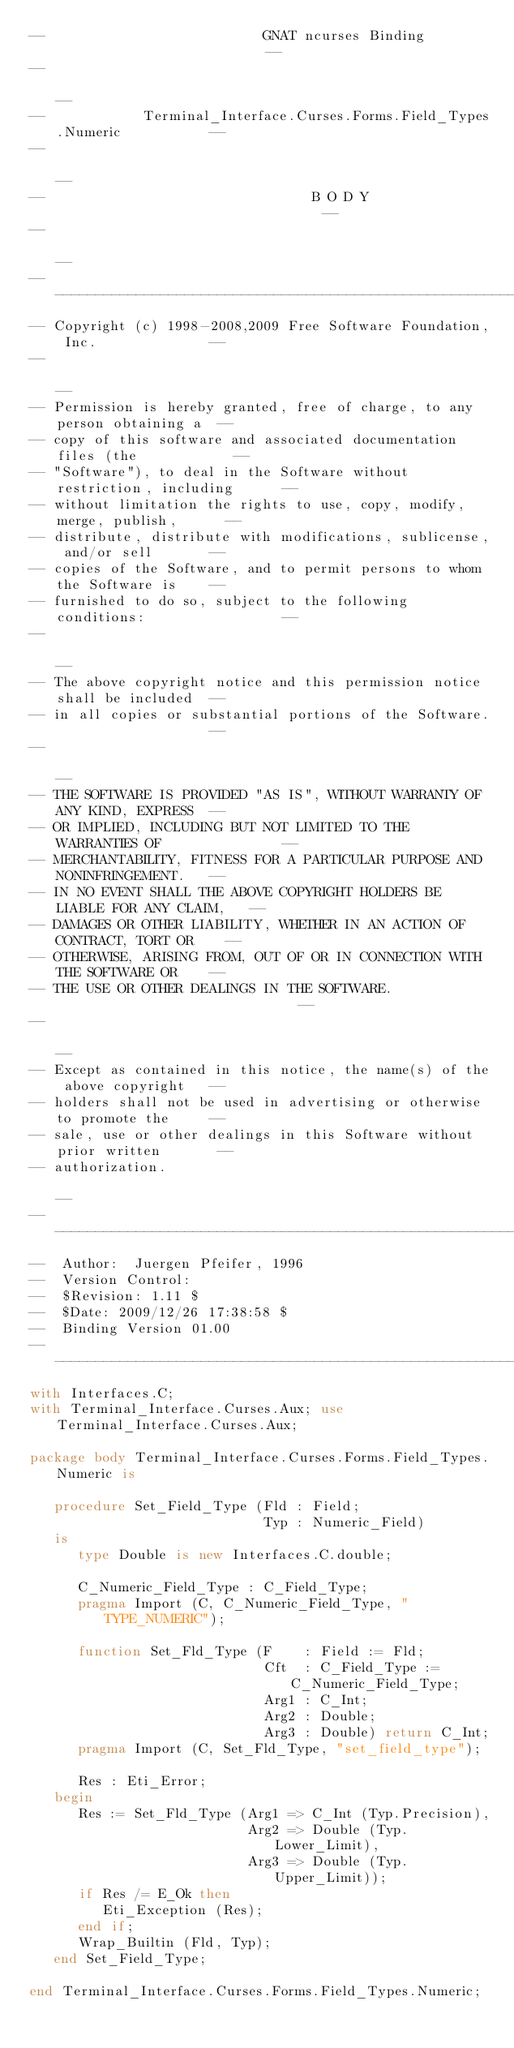<code> <loc_0><loc_0><loc_500><loc_500><_Ada_>--                           GNAT ncurses Binding                           --
--                                                                          --
--            Terminal_Interface.Curses.Forms.Field_Types.Numeric           --
--                                                                          --
--                                 B O D Y                                  --
--                                                                          --
------------------------------------------------------------------------------
-- Copyright (c) 1998-2008,2009 Free Software Foundation, Inc.              --
--                                                                          --
-- Permission is hereby granted, free of charge, to any person obtaining a  --
-- copy of this software and associated documentation files (the            --
-- "Software"), to deal in the Software without restriction, including      --
-- without limitation the rights to use, copy, modify, merge, publish,      --
-- distribute, distribute with modifications, sublicense, and/or sell       --
-- copies of the Software, and to permit persons to whom the Software is    --
-- furnished to do so, subject to the following conditions:                 --
--                                                                          --
-- The above copyright notice and this permission notice shall be included  --
-- in all copies or substantial portions of the Software.                   --
--                                                                          --
-- THE SOFTWARE IS PROVIDED "AS IS", WITHOUT WARRANTY OF ANY KIND, EXPRESS  --
-- OR IMPLIED, INCLUDING BUT NOT LIMITED TO THE WARRANTIES OF               --
-- MERCHANTABILITY, FITNESS FOR A PARTICULAR PURPOSE AND NONINFRINGEMENT.   --
-- IN NO EVENT SHALL THE ABOVE COPYRIGHT HOLDERS BE LIABLE FOR ANY CLAIM,   --
-- DAMAGES OR OTHER LIABILITY, WHETHER IN AN ACTION OF CONTRACT, TORT OR    --
-- OTHERWISE, ARISING FROM, OUT OF OR IN CONNECTION WITH THE SOFTWARE OR    --
-- THE USE OR OTHER DEALINGS IN THE SOFTWARE.                               --
--                                                                          --
-- Except as contained in this notice, the name(s) of the above copyright   --
-- holders shall not be used in advertising or otherwise to promote the     --
-- sale, use or other dealings in this Software without prior written       --
-- authorization.                                                           --
------------------------------------------------------------------------------
--  Author:  Juergen Pfeifer, 1996
--  Version Control:
--  $Revision: 1.11 $
--  $Date: 2009/12/26 17:38:58 $
--  Binding Version 01.00
------------------------------------------------------------------------------
with Interfaces.C;
with Terminal_Interface.Curses.Aux; use Terminal_Interface.Curses.Aux;

package body Terminal_Interface.Curses.Forms.Field_Types.Numeric is

   procedure Set_Field_Type (Fld : Field;
                             Typ : Numeric_Field)
   is
      type Double is new Interfaces.C.double;

      C_Numeric_Field_Type : C_Field_Type;
      pragma Import (C, C_Numeric_Field_Type, "TYPE_NUMERIC");

      function Set_Fld_Type (F    : Field := Fld;
                             Cft  : C_Field_Type := C_Numeric_Field_Type;
                             Arg1 : C_Int;
                             Arg2 : Double;
                             Arg3 : Double) return C_Int;
      pragma Import (C, Set_Fld_Type, "set_field_type");

      Res : Eti_Error;
   begin
      Res := Set_Fld_Type (Arg1 => C_Int (Typ.Precision),
                           Arg2 => Double (Typ.Lower_Limit),
                           Arg3 => Double (Typ.Upper_Limit));
      if Res /= E_Ok then
         Eti_Exception (Res);
      end if;
      Wrap_Builtin (Fld, Typ);
   end Set_Field_Type;

end Terminal_Interface.Curses.Forms.Field_Types.Numeric;
</code> 